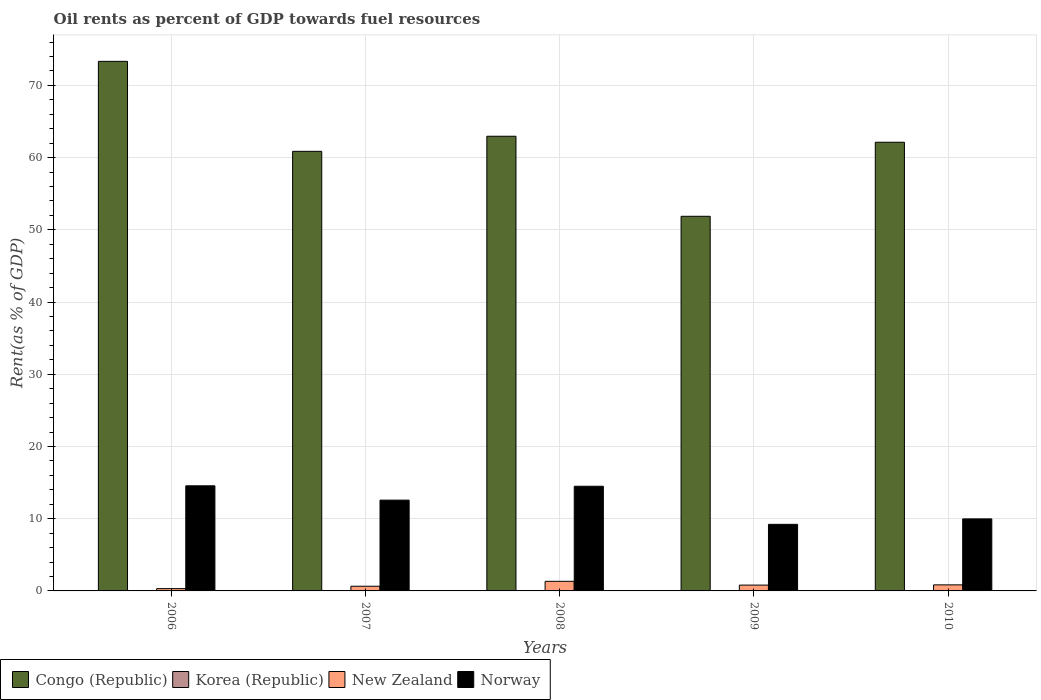How many different coloured bars are there?
Keep it short and to the point. 4. How many bars are there on the 4th tick from the right?
Keep it short and to the point. 4. What is the label of the 3rd group of bars from the left?
Give a very brief answer. 2008. What is the oil rent in Norway in 2010?
Ensure brevity in your answer.  9.97. Across all years, what is the maximum oil rent in Congo (Republic)?
Keep it short and to the point. 73.33. Across all years, what is the minimum oil rent in Norway?
Your response must be concise. 9.22. What is the total oil rent in New Zealand in the graph?
Ensure brevity in your answer.  3.94. What is the difference between the oil rent in New Zealand in 2006 and that in 2010?
Your answer should be very brief. -0.52. What is the difference between the oil rent in New Zealand in 2007 and the oil rent in Norway in 2010?
Your answer should be compact. -9.33. What is the average oil rent in New Zealand per year?
Give a very brief answer. 0.79. In the year 2009, what is the difference between the oil rent in Congo (Republic) and oil rent in Norway?
Give a very brief answer. 42.66. What is the ratio of the oil rent in Norway in 2008 to that in 2010?
Provide a succinct answer. 1.45. What is the difference between the highest and the second highest oil rent in Norway?
Your response must be concise. 0.06. What is the difference between the highest and the lowest oil rent in Congo (Republic)?
Give a very brief answer. 21.45. What does the 2nd bar from the left in 2009 represents?
Make the answer very short. Korea (Republic). What does the 2nd bar from the right in 2006 represents?
Offer a terse response. New Zealand. Is it the case that in every year, the sum of the oil rent in Norway and oil rent in New Zealand is greater than the oil rent in Congo (Republic)?
Give a very brief answer. No. What is the difference between two consecutive major ticks on the Y-axis?
Offer a terse response. 10. Does the graph contain any zero values?
Offer a very short reply. No. Does the graph contain grids?
Offer a very short reply. Yes. Where does the legend appear in the graph?
Ensure brevity in your answer.  Bottom left. How are the legend labels stacked?
Provide a succinct answer. Horizontal. What is the title of the graph?
Your answer should be compact. Oil rents as percent of GDP towards fuel resources. What is the label or title of the Y-axis?
Your response must be concise. Rent(as % of GDP). What is the Rent(as % of GDP) of Congo (Republic) in 2006?
Provide a succinct answer. 73.33. What is the Rent(as % of GDP) in Korea (Republic) in 2006?
Offer a terse response. 0. What is the Rent(as % of GDP) in New Zealand in 2006?
Give a very brief answer. 0.32. What is the Rent(as % of GDP) of Norway in 2006?
Provide a succinct answer. 14.56. What is the Rent(as % of GDP) in Congo (Republic) in 2007?
Offer a terse response. 60.87. What is the Rent(as % of GDP) of Korea (Republic) in 2007?
Make the answer very short. 0. What is the Rent(as % of GDP) of New Zealand in 2007?
Provide a short and direct response. 0.65. What is the Rent(as % of GDP) of Norway in 2007?
Give a very brief answer. 12.57. What is the Rent(as % of GDP) in Congo (Republic) in 2008?
Offer a very short reply. 62.96. What is the Rent(as % of GDP) in Korea (Republic) in 2008?
Ensure brevity in your answer.  0. What is the Rent(as % of GDP) in New Zealand in 2008?
Offer a very short reply. 1.33. What is the Rent(as % of GDP) in Norway in 2008?
Ensure brevity in your answer.  14.49. What is the Rent(as % of GDP) in Congo (Republic) in 2009?
Make the answer very short. 51.88. What is the Rent(as % of GDP) in Korea (Republic) in 2009?
Ensure brevity in your answer.  0. What is the Rent(as % of GDP) of New Zealand in 2009?
Provide a succinct answer. 0.81. What is the Rent(as % of GDP) in Norway in 2009?
Your answer should be compact. 9.22. What is the Rent(as % of GDP) in Congo (Republic) in 2010?
Offer a very short reply. 62.13. What is the Rent(as % of GDP) of Korea (Republic) in 2010?
Your answer should be very brief. 0. What is the Rent(as % of GDP) of New Zealand in 2010?
Your response must be concise. 0.84. What is the Rent(as % of GDP) of Norway in 2010?
Your answer should be very brief. 9.97. Across all years, what is the maximum Rent(as % of GDP) of Congo (Republic)?
Offer a very short reply. 73.33. Across all years, what is the maximum Rent(as % of GDP) of Korea (Republic)?
Provide a succinct answer. 0. Across all years, what is the maximum Rent(as % of GDP) of New Zealand?
Give a very brief answer. 1.33. Across all years, what is the maximum Rent(as % of GDP) of Norway?
Offer a terse response. 14.56. Across all years, what is the minimum Rent(as % of GDP) of Congo (Republic)?
Offer a very short reply. 51.88. Across all years, what is the minimum Rent(as % of GDP) in Korea (Republic)?
Make the answer very short. 0. Across all years, what is the minimum Rent(as % of GDP) of New Zealand?
Make the answer very short. 0.32. Across all years, what is the minimum Rent(as % of GDP) in Norway?
Offer a terse response. 9.22. What is the total Rent(as % of GDP) of Congo (Republic) in the graph?
Your answer should be very brief. 311.18. What is the total Rent(as % of GDP) in Korea (Republic) in the graph?
Your answer should be compact. 0.01. What is the total Rent(as % of GDP) of New Zealand in the graph?
Give a very brief answer. 3.94. What is the total Rent(as % of GDP) in Norway in the graph?
Your answer should be compact. 60.82. What is the difference between the Rent(as % of GDP) of Congo (Republic) in 2006 and that in 2007?
Offer a very short reply. 12.46. What is the difference between the Rent(as % of GDP) in Korea (Republic) in 2006 and that in 2007?
Offer a very short reply. 0. What is the difference between the Rent(as % of GDP) of New Zealand in 2006 and that in 2007?
Keep it short and to the point. -0.33. What is the difference between the Rent(as % of GDP) in Norway in 2006 and that in 2007?
Your answer should be very brief. 1.98. What is the difference between the Rent(as % of GDP) of Congo (Republic) in 2006 and that in 2008?
Give a very brief answer. 10.37. What is the difference between the Rent(as % of GDP) in New Zealand in 2006 and that in 2008?
Your response must be concise. -1.01. What is the difference between the Rent(as % of GDP) of Norway in 2006 and that in 2008?
Make the answer very short. 0.06. What is the difference between the Rent(as % of GDP) in Congo (Republic) in 2006 and that in 2009?
Provide a succinct answer. 21.45. What is the difference between the Rent(as % of GDP) of New Zealand in 2006 and that in 2009?
Provide a short and direct response. -0.49. What is the difference between the Rent(as % of GDP) of Norway in 2006 and that in 2009?
Your answer should be compact. 5.33. What is the difference between the Rent(as % of GDP) of Congo (Republic) in 2006 and that in 2010?
Offer a very short reply. 11.2. What is the difference between the Rent(as % of GDP) of Korea (Republic) in 2006 and that in 2010?
Give a very brief answer. -0. What is the difference between the Rent(as % of GDP) in New Zealand in 2006 and that in 2010?
Offer a terse response. -0.52. What is the difference between the Rent(as % of GDP) of Norway in 2006 and that in 2010?
Ensure brevity in your answer.  4.58. What is the difference between the Rent(as % of GDP) of Congo (Republic) in 2007 and that in 2008?
Make the answer very short. -2.09. What is the difference between the Rent(as % of GDP) in Korea (Republic) in 2007 and that in 2008?
Offer a very short reply. -0. What is the difference between the Rent(as % of GDP) of New Zealand in 2007 and that in 2008?
Provide a succinct answer. -0.68. What is the difference between the Rent(as % of GDP) in Norway in 2007 and that in 2008?
Ensure brevity in your answer.  -1.92. What is the difference between the Rent(as % of GDP) of Congo (Republic) in 2007 and that in 2009?
Give a very brief answer. 8.99. What is the difference between the Rent(as % of GDP) of Korea (Republic) in 2007 and that in 2009?
Provide a succinct answer. -0. What is the difference between the Rent(as % of GDP) in New Zealand in 2007 and that in 2009?
Give a very brief answer. -0.16. What is the difference between the Rent(as % of GDP) of Norway in 2007 and that in 2009?
Provide a succinct answer. 3.35. What is the difference between the Rent(as % of GDP) of Congo (Republic) in 2007 and that in 2010?
Provide a succinct answer. -1.26. What is the difference between the Rent(as % of GDP) in Korea (Republic) in 2007 and that in 2010?
Ensure brevity in your answer.  -0. What is the difference between the Rent(as % of GDP) in New Zealand in 2007 and that in 2010?
Your answer should be compact. -0.19. What is the difference between the Rent(as % of GDP) of Norway in 2007 and that in 2010?
Make the answer very short. 2.6. What is the difference between the Rent(as % of GDP) of Congo (Republic) in 2008 and that in 2009?
Offer a very short reply. 11.09. What is the difference between the Rent(as % of GDP) of Korea (Republic) in 2008 and that in 2009?
Your answer should be very brief. -0. What is the difference between the Rent(as % of GDP) of New Zealand in 2008 and that in 2009?
Provide a short and direct response. 0.52. What is the difference between the Rent(as % of GDP) of Norway in 2008 and that in 2009?
Offer a terse response. 5.27. What is the difference between the Rent(as % of GDP) of Congo (Republic) in 2008 and that in 2010?
Ensure brevity in your answer.  0.83. What is the difference between the Rent(as % of GDP) in Korea (Republic) in 2008 and that in 2010?
Your response must be concise. -0. What is the difference between the Rent(as % of GDP) of New Zealand in 2008 and that in 2010?
Offer a very short reply. 0.49. What is the difference between the Rent(as % of GDP) of Norway in 2008 and that in 2010?
Offer a very short reply. 4.52. What is the difference between the Rent(as % of GDP) of Congo (Republic) in 2009 and that in 2010?
Keep it short and to the point. -10.25. What is the difference between the Rent(as % of GDP) of Korea (Republic) in 2009 and that in 2010?
Your answer should be compact. -0. What is the difference between the Rent(as % of GDP) in New Zealand in 2009 and that in 2010?
Give a very brief answer. -0.03. What is the difference between the Rent(as % of GDP) of Norway in 2009 and that in 2010?
Your response must be concise. -0.75. What is the difference between the Rent(as % of GDP) in Congo (Republic) in 2006 and the Rent(as % of GDP) in Korea (Republic) in 2007?
Make the answer very short. 73.33. What is the difference between the Rent(as % of GDP) in Congo (Republic) in 2006 and the Rent(as % of GDP) in New Zealand in 2007?
Provide a succinct answer. 72.68. What is the difference between the Rent(as % of GDP) in Congo (Republic) in 2006 and the Rent(as % of GDP) in Norway in 2007?
Offer a terse response. 60.76. What is the difference between the Rent(as % of GDP) in Korea (Republic) in 2006 and the Rent(as % of GDP) in New Zealand in 2007?
Give a very brief answer. -0.65. What is the difference between the Rent(as % of GDP) in Korea (Republic) in 2006 and the Rent(as % of GDP) in Norway in 2007?
Ensure brevity in your answer.  -12.57. What is the difference between the Rent(as % of GDP) in New Zealand in 2006 and the Rent(as % of GDP) in Norway in 2007?
Your response must be concise. -12.25. What is the difference between the Rent(as % of GDP) of Congo (Republic) in 2006 and the Rent(as % of GDP) of Korea (Republic) in 2008?
Provide a short and direct response. 73.33. What is the difference between the Rent(as % of GDP) of Congo (Republic) in 2006 and the Rent(as % of GDP) of New Zealand in 2008?
Ensure brevity in your answer.  72. What is the difference between the Rent(as % of GDP) of Congo (Republic) in 2006 and the Rent(as % of GDP) of Norway in 2008?
Give a very brief answer. 58.84. What is the difference between the Rent(as % of GDP) of Korea (Republic) in 2006 and the Rent(as % of GDP) of New Zealand in 2008?
Your answer should be compact. -1.33. What is the difference between the Rent(as % of GDP) of Korea (Republic) in 2006 and the Rent(as % of GDP) of Norway in 2008?
Ensure brevity in your answer.  -14.49. What is the difference between the Rent(as % of GDP) of New Zealand in 2006 and the Rent(as % of GDP) of Norway in 2008?
Your response must be concise. -14.17. What is the difference between the Rent(as % of GDP) of Congo (Republic) in 2006 and the Rent(as % of GDP) of Korea (Republic) in 2009?
Provide a short and direct response. 73.33. What is the difference between the Rent(as % of GDP) in Congo (Republic) in 2006 and the Rent(as % of GDP) in New Zealand in 2009?
Offer a very short reply. 72.53. What is the difference between the Rent(as % of GDP) of Congo (Republic) in 2006 and the Rent(as % of GDP) of Norway in 2009?
Give a very brief answer. 64.11. What is the difference between the Rent(as % of GDP) in Korea (Republic) in 2006 and the Rent(as % of GDP) in New Zealand in 2009?
Make the answer very short. -0.8. What is the difference between the Rent(as % of GDP) of Korea (Republic) in 2006 and the Rent(as % of GDP) of Norway in 2009?
Your answer should be compact. -9.22. What is the difference between the Rent(as % of GDP) in New Zealand in 2006 and the Rent(as % of GDP) in Norway in 2009?
Keep it short and to the point. -8.9. What is the difference between the Rent(as % of GDP) in Congo (Republic) in 2006 and the Rent(as % of GDP) in Korea (Republic) in 2010?
Your answer should be compact. 73.33. What is the difference between the Rent(as % of GDP) of Congo (Republic) in 2006 and the Rent(as % of GDP) of New Zealand in 2010?
Your answer should be compact. 72.49. What is the difference between the Rent(as % of GDP) in Congo (Republic) in 2006 and the Rent(as % of GDP) in Norway in 2010?
Ensure brevity in your answer.  63.36. What is the difference between the Rent(as % of GDP) in Korea (Republic) in 2006 and the Rent(as % of GDP) in New Zealand in 2010?
Keep it short and to the point. -0.84. What is the difference between the Rent(as % of GDP) in Korea (Republic) in 2006 and the Rent(as % of GDP) in Norway in 2010?
Your answer should be very brief. -9.97. What is the difference between the Rent(as % of GDP) of New Zealand in 2006 and the Rent(as % of GDP) of Norway in 2010?
Offer a very short reply. -9.65. What is the difference between the Rent(as % of GDP) in Congo (Republic) in 2007 and the Rent(as % of GDP) in Korea (Republic) in 2008?
Your answer should be very brief. 60.87. What is the difference between the Rent(as % of GDP) in Congo (Republic) in 2007 and the Rent(as % of GDP) in New Zealand in 2008?
Your answer should be very brief. 59.54. What is the difference between the Rent(as % of GDP) of Congo (Republic) in 2007 and the Rent(as % of GDP) of Norway in 2008?
Provide a short and direct response. 46.38. What is the difference between the Rent(as % of GDP) of Korea (Republic) in 2007 and the Rent(as % of GDP) of New Zealand in 2008?
Your answer should be compact. -1.33. What is the difference between the Rent(as % of GDP) in Korea (Republic) in 2007 and the Rent(as % of GDP) in Norway in 2008?
Offer a very short reply. -14.49. What is the difference between the Rent(as % of GDP) of New Zealand in 2007 and the Rent(as % of GDP) of Norway in 2008?
Offer a very short reply. -13.85. What is the difference between the Rent(as % of GDP) of Congo (Republic) in 2007 and the Rent(as % of GDP) of Korea (Republic) in 2009?
Keep it short and to the point. 60.87. What is the difference between the Rent(as % of GDP) in Congo (Republic) in 2007 and the Rent(as % of GDP) in New Zealand in 2009?
Your response must be concise. 60.07. What is the difference between the Rent(as % of GDP) of Congo (Republic) in 2007 and the Rent(as % of GDP) of Norway in 2009?
Offer a terse response. 51.65. What is the difference between the Rent(as % of GDP) of Korea (Republic) in 2007 and the Rent(as % of GDP) of New Zealand in 2009?
Your answer should be compact. -0.8. What is the difference between the Rent(as % of GDP) of Korea (Republic) in 2007 and the Rent(as % of GDP) of Norway in 2009?
Your response must be concise. -9.22. What is the difference between the Rent(as % of GDP) in New Zealand in 2007 and the Rent(as % of GDP) in Norway in 2009?
Your answer should be compact. -8.57. What is the difference between the Rent(as % of GDP) of Congo (Republic) in 2007 and the Rent(as % of GDP) of Korea (Republic) in 2010?
Provide a short and direct response. 60.87. What is the difference between the Rent(as % of GDP) in Congo (Republic) in 2007 and the Rent(as % of GDP) in New Zealand in 2010?
Your answer should be compact. 60.03. What is the difference between the Rent(as % of GDP) in Congo (Republic) in 2007 and the Rent(as % of GDP) in Norway in 2010?
Ensure brevity in your answer.  50.9. What is the difference between the Rent(as % of GDP) of Korea (Republic) in 2007 and the Rent(as % of GDP) of New Zealand in 2010?
Offer a very short reply. -0.84. What is the difference between the Rent(as % of GDP) in Korea (Republic) in 2007 and the Rent(as % of GDP) in Norway in 2010?
Make the answer very short. -9.97. What is the difference between the Rent(as % of GDP) of New Zealand in 2007 and the Rent(as % of GDP) of Norway in 2010?
Offer a very short reply. -9.33. What is the difference between the Rent(as % of GDP) of Congo (Republic) in 2008 and the Rent(as % of GDP) of Korea (Republic) in 2009?
Provide a short and direct response. 62.96. What is the difference between the Rent(as % of GDP) in Congo (Republic) in 2008 and the Rent(as % of GDP) in New Zealand in 2009?
Offer a very short reply. 62.16. What is the difference between the Rent(as % of GDP) in Congo (Republic) in 2008 and the Rent(as % of GDP) in Norway in 2009?
Your answer should be compact. 53.74. What is the difference between the Rent(as % of GDP) in Korea (Republic) in 2008 and the Rent(as % of GDP) in New Zealand in 2009?
Your answer should be very brief. -0.8. What is the difference between the Rent(as % of GDP) of Korea (Republic) in 2008 and the Rent(as % of GDP) of Norway in 2009?
Offer a very short reply. -9.22. What is the difference between the Rent(as % of GDP) in New Zealand in 2008 and the Rent(as % of GDP) in Norway in 2009?
Your response must be concise. -7.89. What is the difference between the Rent(as % of GDP) in Congo (Republic) in 2008 and the Rent(as % of GDP) in Korea (Republic) in 2010?
Give a very brief answer. 62.96. What is the difference between the Rent(as % of GDP) in Congo (Republic) in 2008 and the Rent(as % of GDP) in New Zealand in 2010?
Provide a succinct answer. 62.13. What is the difference between the Rent(as % of GDP) in Congo (Republic) in 2008 and the Rent(as % of GDP) in Norway in 2010?
Your answer should be compact. 52.99. What is the difference between the Rent(as % of GDP) in Korea (Republic) in 2008 and the Rent(as % of GDP) in New Zealand in 2010?
Your response must be concise. -0.84. What is the difference between the Rent(as % of GDP) of Korea (Republic) in 2008 and the Rent(as % of GDP) of Norway in 2010?
Offer a very short reply. -9.97. What is the difference between the Rent(as % of GDP) of New Zealand in 2008 and the Rent(as % of GDP) of Norway in 2010?
Give a very brief answer. -8.64. What is the difference between the Rent(as % of GDP) of Congo (Republic) in 2009 and the Rent(as % of GDP) of Korea (Republic) in 2010?
Keep it short and to the point. 51.88. What is the difference between the Rent(as % of GDP) of Congo (Republic) in 2009 and the Rent(as % of GDP) of New Zealand in 2010?
Provide a short and direct response. 51.04. What is the difference between the Rent(as % of GDP) of Congo (Republic) in 2009 and the Rent(as % of GDP) of Norway in 2010?
Make the answer very short. 41.9. What is the difference between the Rent(as % of GDP) in Korea (Republic) in 2009 and the Rent(as % of GDP) in New Zealand in 2010?
Ensure brevity in your answer.  -0.84. What is the difference between the Rent(as % of GDP) of Korea (Republic) in 2009 and the Rent(as % of GDP) of Norway in 2010?
Your answer should be compact. -9.97. What is the difference between the Rent(as % of GDP) of New Zealand in 2009 and the Rent(as % of GDP) of Norway in 2010?
Offer a very short reply. -9.17. What is the average Rent(as % of GDP) of Congo (Republic) per year?
Make the answer very short. 62.24. What is the average Rent(as % of GDP) in Korea (Republic) per year?
Keep it short and to the point. 0. What is the average Rent(as % of GDP) of New Zealand per year?
Offer a very short reply. 0.79. What is the average Rent(as % of GDP) in Norway per year?
Provide a short and direct response. 12.16. In the year 2006, what is the difference between the Rent(as % of GDP) in Congo (Republic) and Rent(as % of GDP) in Korea (Republic)?
Provide a succinct answer. 73.33. In the year 2006, what is the difference between the Rent(as % of GDP) of Congo (Republic) and Rent(as % of GDP) of New Zealand?
Your answer should be very brief. 73.01. In the year 2006, what is the difference between the Rent(as % of GDP) in Congo (Republic) and Rent(as % of GDP) in Norway?
Your response must be concise. 58.78. In the year 2006, what is the difference between the Rent(as % of GDP) in Korea (Republic) and Rent(as % of GDP) in New Zealand?
Give a very brief answer. -0.32. In the year 2006, what is the difference between the Rent(as % of GDP) in Korea (Republic) and Rent(as % of GDP) in Norway?
Your answer should be very brief. -14.55. In the year 2006, what is the difference between the Rent(as % of GDP) of New Zealand and Rent(as % of GDP) of Norway?
Keep it short and to the point. -14.24. In the year 2007, what is the difference between the Rent(as % of GDP) of Congo (Republic) and Rent(as % of GDP) of Korea (Republic)?
Provide a short and direct response. 60.87. In the year 2007, what is the difference between the Rent(as % of GDP) in Congo (Republic) and Rent(as % of GDP) in New Zealand?
Offer a terse response. 60.22. In the year 2007, what is the difference between the Rent(as % of GDP) in Congo (Republic) and Rent(as % of GDP) in Norway?
Make the answer very short. 48.3. In the year 2007, what is the difference between the Rent(as % of GDP) in Korea (Republic) and Rent(as % of GDP) in New Zealand?
Give a very brief answer. -0.65. In the year 2007, what is the difference between the Rent(as % of GDP) in Korea (Republic) and Rent(as % of GDP) in Norway?
Provide a succinct answer. -12.57. In the year 2007, what is the difference between the Rent(as % of GDP) in New Zealand and Rent(as % of GDP) in Norway?
Your response must be concise. -11.92. In the year 2008, what is the difference between the Rent(as % of GDP) in Congo (Republic) and Rent(as % of GDP) in Korea (Republic)?
Make the answer very short. 62.96. In the year 2008, what is the difference between the Rent(as % of GDP) in Congo (Republic) and Rent(as % of GDP) in New Zealand?
Make the answer very short. 61.63. In the year 2008, what is the difference between the Rent(as % of GDP) in Congo (Republic) and Rent(as % of GDP) in Norway?
Your answer should be compact. 48.47. In the year 2008, what is the difference between the Rent(as % of GDP) of Korea (Republic) and Rent(as % of GDP) of New Zealand?
Provide a succinct answer. -1.33. In the year 2008, what is the difference between the Rent(as % of GDP) of Korea (Republic) and Rent(as % of GDP) of Norway?
Your answer should be very brief. -14.49. In the year 2008, what is the difference between the Rent(as % of GDP) of New Zealand and Rent(as % of GDP) of Norway?
Offer a very short reply. -13.16. In the year 2009, what is the difference between the Rent(as % of GDP) of Congo (Republic) and Rent(as % of GDP) of Korea (Republic)?
Provide a short and direct response. 51.88. In the year 2009, what is the difference between the Rent(as % of GDP) in Congo (Republic) and Rent(as % of GDP) in New Zealand?
Your answer should be compact. 51.07. In the year 2009, what is the difference between the Rent(as % of GDP) of Congo (Republic) and Rent(as % of GDP) of Norway?
Provide a short and direct response. 42.66. In the year 2009, what is the difference between the Rent(as % of GDP) in Korea (Republic) and Rent(as % of GDP) in New Zealand?
Keep it short and to the point. -0.8. In the year 2009, what is the difference between the Rent(as % of GDP) in Korea (Republic) and Rent(as % of GDP) in Norway?
Your response must be concise. -9.22. In the year 2009, what is the difference between the Rent(as % of GDP) of New Zealand and Rent(as % of GDP) of Norway?
Your answer should be very brief. -8.42. In the year 2010, what is the difference between the Rent(as % of GDP) of Congo (Republic) and Rent(as % of GDP) of Korea (Republic)?
Give a very brief answer. 62.13. In the year 2010, what is the difference between the Rent(as % of GDP) in Congo (Republic) and Rent(as % of GDP) in New Zealand?
Ensure brevity in your answer.  61.29. In the year 2010, what is the difference between the Rent(as % of GDP) of Congo (Republic) and Rent(as % of GDP) of Norway?
Offer a very short reply. 52.16. In the year 2010, what is the difference between the Rent(as % of GDP) of Korea (Republic) and Rent(as % of GDP) of New Zealand?
Provide a succinct answer. -0.84. In the year 2010, what is the difference between the Rent(as % of GDP) of Korea (Republic) and Rent(as % of GDP) of Norway?
Provide a succinct answer. -9.97. In the year 2010, what is the difference between the Rent(as % of GDP) in New Zealand and Rent(as % of GDP) in Norway?
Ensure brevity in your answer.  -9.14. What is the ratio of the Rent(as % of GDP) in Congo (Republic) in 2006 to that in 2007?
Offer a terse response. 1.2. What is the ratio of the Rent(as % of GDP) in Korea (Republic) in 2006 to that in 2007?
Offer a terse response. 1.46. What is the ratio of the Rent(as % of GDP) of New Zealand in 2006 to that in 2007?
Your response must be concise. 0.49. What is the ratio of the Rent(as % of GDP) in Norway in 2006 to that in 2007?
Provide a succinct answer. 1.16. What is the ratio of the Rent(as % of GDP) in Congo (Republic) in 2006 to that in 2008?
Provide a succinct answer. 1.16. What is the ratio of the Rent(as % of GDP) in Korea (Republic) in 2006 to that in 2008?
Provide a short and direct response. 1.4. What is the ratio of the Rent(as % of GDP) of New Zealand in 2006 to that in 2008?
Your response must be concise. 0.24. What is the ratio of the Rent(as % of GDP) of Congo (Republic) in 2006 to that in 2009?
Offer a very short reply. 1.41. What is the ratio of the Rent(as % of GDP) in Korea (Republic) in 2006 to that in 2009?
Make the answer very short. 1.08. What is the ratio of the Rent(as % of GDP) in New Zealand in 2006 to that in 2009?
Make the answer very short. 0.4. What is the ratio of the Rent(as % of GDP) of Norway in 2006 to that in 2009?
Keep it short and to the point. 1.58. What is the ratio of the Rent(as % of GDP) of Congo (Republic) in 2006 to that in 2010?
Give a very brief answer. 1.18. What is the ratio of the Rent(as % of GDP) in Korea (Republic) in 2006 to that in 2010?
Make the answer very short. 0.79. What is the ratio of the Rent(as % of GDP) of New Zealand in 2006 to that in 2010?
Your response must be concise. 0.38. What is the ratio of the Rent(as % of GDP) of Norway in 2006 to that in 2010?
Provide a short and direct response. 1.46. What is the ratio of the Rent(as % of GDP) in Congo (Republic) in 2007 to that in 2008?
Give a very brief answer. 0.97. What is the ratio of the Rent(as % of GDP) in New Zealand in 2007 to that in 2008?
Make the answer very short. 0.49. What is the ratio of the Rent(as % of GDP) of Norway in 2007 to that in 2008?
Keep it short and to the point. 0.87. What is the ratio of the Rent(as % of GDP) of Congo (Republic) in 2007 to that in 2009?
Keep it short and to the point. 1.17. What is the ratio of the Rent(as % of GDP) in Korea (Republic) in 2007 to that in 2009?
Ensure brevity in your answer.  0.74. What is the ratio of the Rent(as % of GDP) of New Zealand in 2007 to that in 2009?
Ensure brevity in your answer.  0.8. What is the ratio of the Rent(as % of GDP) in Norway in 2007 to that in 2009?
Your answer should be very brief. 1.36. What is the ratio of the Rent(as % of GDP) in Congo (Republic) in 2007 to that in 2010?
Your answer should be very brief. 0.98. What is the ratio of the Rent(as % of GDP) of Korea (Republic) in 2007 to that in 2010?
Provide a succinct answer. 0.54. What is the ratio of the Rent(as % of GDP) of New Zealand in 2007 to that in 2010?
Ensure brevity in your answer.  0.77. What is the ratio of the Rent(as % of GDP) in Norway in 2007 to that in 2010?
Provide a short and direct response. 1.26. What is the ratio of the Rent(as % of GDP) in Congo (Republic) in 2008 to that in 2009?
Provide a short and direct response. 1.21. What is the ratio of the Rent(as % of GDP) in Korea (Republic) in 2008 to that in 2009?
Keep it short and to the point. 0.77. What is the ratio of the Rent(as % of GDP) of New Zealand in 2008 to that in 2009?
Make the answer very short. 1.65. What is the ratio of the Rent(as % of GDP) of Norway in 2008 to that in 2009?
Your response must be concise. 1.57. What is the ratio of the Rent(as % of GDP) of Congo (Republic) in 2008 to that in 2010?
Offer a terse response. 1.01. What is the ratio of the Rent(as % of GDP) in Korea (Republic) in 2008 to that in 2010?
Your answer should be very brief. 0.56. What is the ratio of the Rent(as % of GDP) of New Zealand in 2008 to that in 2010?
Make the answer very short. 1.59. What is the ratio of the Rent(as % of GDP) in Norway in 2008 to that in 2010?
Your answer should be very brief. 1.45. What is the ratio of the Rent(as % of GDP) in Congo (Republic) in 2009 to that in 2010?
Give a very brief answer. 0.83. What is the ratio of the Rent(as % of GDP) of Korea (Republic) in 2009 to that in 2010?
Make the answer very short. 0.73. What is the ratio of the Rent(as % of GDP) of New Zealand in 2009 to that in 2010?
Give a very brief answer. 0.96. What is the ratio of the Rent(as % of GDP) in Norway in 2009 to that in 2010?
Your answer should be compact. 0.92. What is the difference between the highest and the second highest Rent(as % of GDP) in Congo (Republic)?
Offer a very short reply. 10.37. What is the difference between the highest and the second highest Rent(as % of GDP) in New Zealand?
Your answer should be compact. 0.49. What is the difference between the highest and the second highest Rent(as % of GDP) in Norway?
Make the answer very short. 0.06. What is the difference between the highest and the lowest Rent(as % of GDP) in Congo (Republic)?
Give a very brief answer. 21.45. What is the difference between the highest and the lowest Rent(as % of GDP) of Korea (Republic)?
Provide a short and direct response. 0. What is the difference between the highest and the lowest Rent(as % of GDP) in New Zealand?
Your answer should be compact. 1.01. What is the difference between the highest and the lowest Rent(as % of GDP) of Norway?
Your answer should be compact. 5.33. 